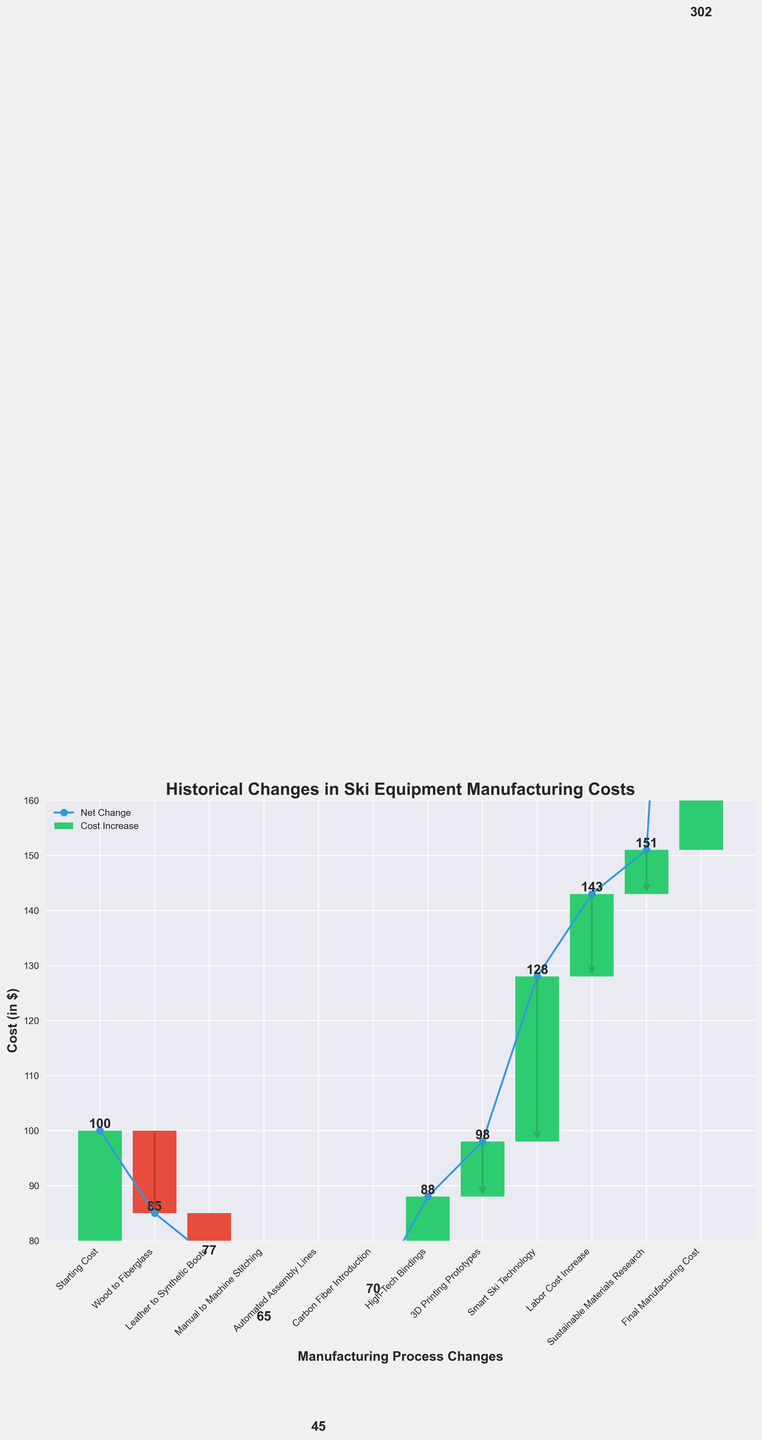How many categories are represented in the figure? There are distinct data points represented by the categories in the figure. By counting the labels along the x-axis, we can determine the number of categories.
Answer: 11 What is the final manufacturing cost? The final manufacturing cost is represented by the last cumulative value in the series. By looking at the y-axis value directly above the "Final Manufacturing Cost" label, we can determine this value.
Answer: 151 Which category contributed the most to reducing costs? To find the category that reduced costs the most, we look for the category with the largest negative value. By examining the height and direction of the bars, "Automated Assembly Lines" has the most significant decrease.
Answer: Automated Assembly Lines How does the introduction of carbon fiber impact costs compared to high-tech bindings? Compare the value changes associated with "Carbon Fiber Introduction" (+25) and "High-Tech Bindings" (+18). The difference indicates how each technology impacted costs relative to each other.
Answer: Carbon Fiber Introduction increased it more What was the cumulative cost after the introduction of smart ski technology? To find the cumulative cost right after "Smart Ski Technology," we sum the previous steps' value changes up to and including this point. Cumulative values before this point can be summed, and the result at "Smart Ski Technology" is 145.
Answer: 145 How much did sustainable materials research impact the manufacturing cost? We look at the value associated with "Sustainable Materials Research," which is shown as a change in the chart. This value tells us the direct impact on manufacturing costs.
Answer: 8 Which manufacturing change caused the first increase in costs? The first positive value indicates the first increase in costs. By checking values sequentially, "Carbon Fiber Introduction" is the first positive value after reductions.
Answer: Carbon Fiber Introduction What is the net change in cost due to advances in ski technology like high-tech bindings and smart ski technology? Sum the changes from "High-Tech Bindings" (+18) and "Smart Ski Technology" (+30) to get the net change from technological advances.
Answer: 48 How does the labor cost increase compare to the synthetic boots transition regarding cost impact? Compare the values associated with "Leather to Synthetic Boots" (-8) and "Labor Cost Increase" (+15). This comparison shows one cost savings and one cost increase, with labor having a greater impact.
Answer: Labor Cost Increase had a greater impact What is the overall net change in manufacturing costs from the starting cost to the final manufacturing cost? Subtract the starting cost (100) from the final manufacturing cost (151) to find the overall net change.
Answer: 51 